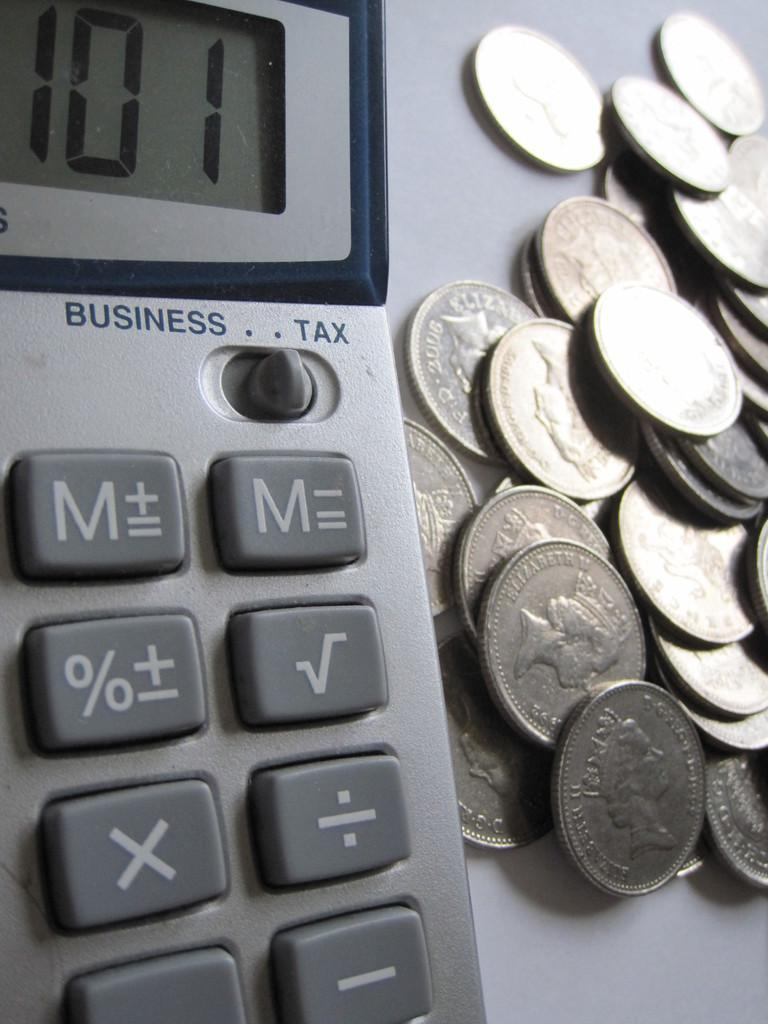<image>
Share a concise interpretation of the image provided. A large pile of silver coins on a table next to a business type calculator. 